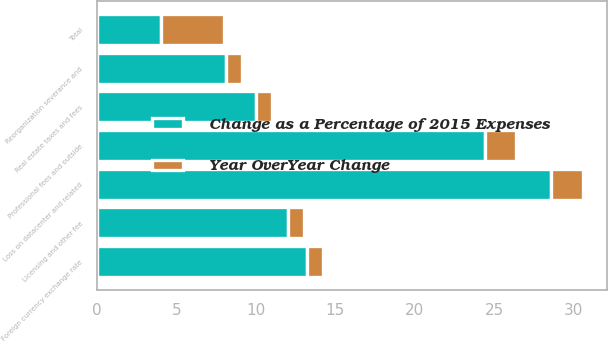Convert chart. <chart><loc_0><loc_0><loc_500><loc_500><stacked_bar_chart><ecel><fcel>Loss on datacenter and related<fcel>Professional fees and outside<fcel>Foreign currency exchange rate<fcel>Licensing and other fee<fcel>Reorganization severance and<fcel>Real estate taxes and fees<fcel>Total<nl><fcel>Change as a Percentage of 2015 Expenses<fcel>28.6<fcel>24.4<fcel>13.2<fcel>12<fcel>8.1<fcel>10<fcel>4<nl><fcel>Year OverYear Change<fcel>2<fcel>2<fcel>1<fcel>1<fcel>1<fcel>1<fcel>4<nl></chart> 